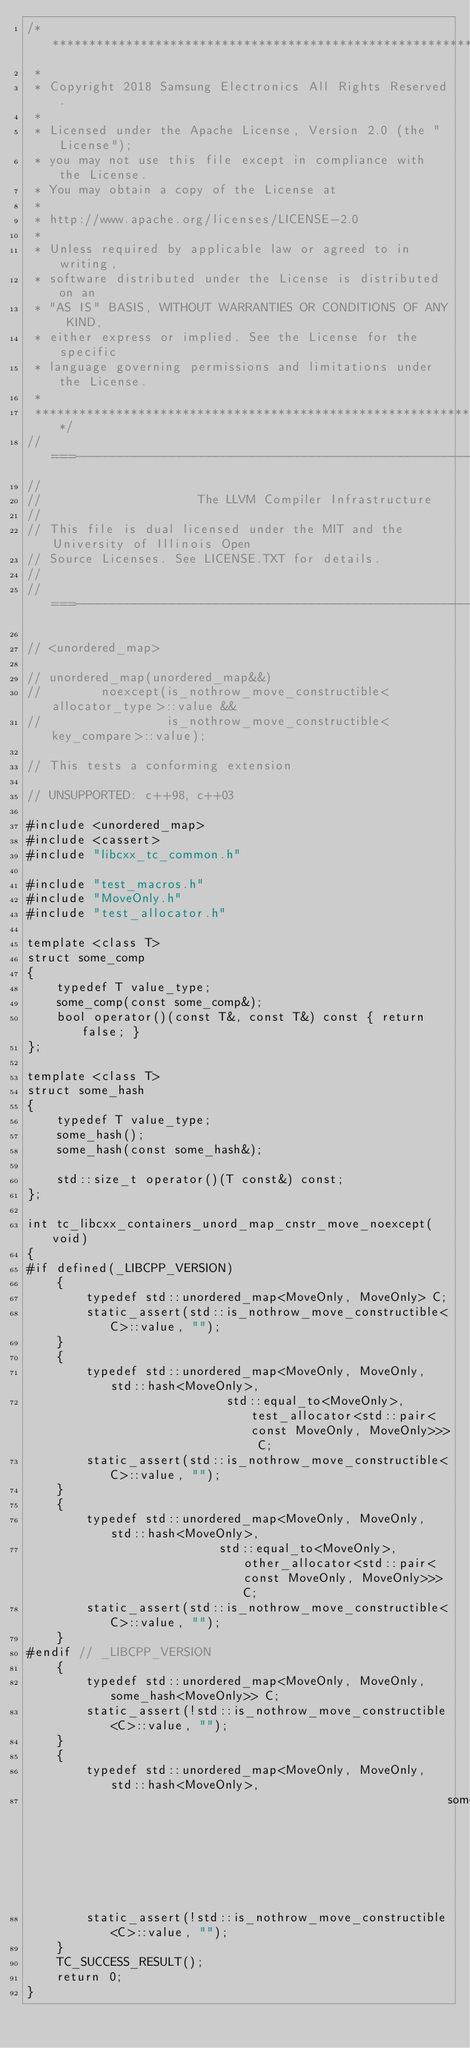<code> <loc_0><loc_0><loc_500><loc_500><_C++_>/****************************************************************************
 *
 * Copyright 2018 Samsung Electronics All Rights Reserved.
 *
 * Licensed under the Apache License, Version 2.0 (the "License");
 * you may not use this file except in compliance with the License.
 * You may obtain a copy of the License at
 *
 * http://www.apache.org/licenses/LICENSE-2.0
 *
 * Unless required by applicable law or agreed to in writing,
 * software distributed under the License is distributed on an
 * "AS IS" BASIS, WITHOUT WARRANTIES OR CONDITIONS OF ANY KIND,
 * either express or implied. See the License for the specific
 * language governing permissions and limitations under the License.
 *
 ****************************************************************************/
//===----------------------------------------------------------------------===//
//
//                     The LLVM Compiler Infrastructure
//
// This file is dual licensed under the MIT and the University of Illinois Open
// Source Licenses. See LICENSE.TXT for details.
//
//===----------------------------------------------------------------------===//

// <unordered_map>

// unordered_map(unordered_map&&)
//        noexcept(is_nothrow_move_constructible<allocator_type>::value &&
//                 is_nothrow_move_constructible<key_compare>::value);

// This tests a conforming extension

// UNSUPPORTED: c++98, c++03

#include <unordered_map>
#include <cassert>
#include "libcxx_tc_common.h"

#include "test_macros.h"
#include "MoveOnly.h"
#include "test_allocator.h"

template <class T>
struct some_comp
{
    typedef T value_type;
    some_comp(const some_comp&);
    bool operator()(const T&, const T&) const { return false; }
};

template <class T>
struct some_hash
{
    typedef T value_type;
    some_hash();
    some_hash(const some_hash&);

    std::size_t operator()(T const&) const;
};

int tc_libcxx_containers_unord_map_cnstr_move_noexcept(void)
{
#if defined(_LIBCPP_VERSION)
    {
        typedef std::unordered_map<MoveOnly, MoveOnly> C;
        static_assert(std::is_nothrow_move_constructible<C>::value, "");
    }
    {
        typedef std::unordered_map<MoveOnly, MoveOnly, std::hash<MoveOnly>,
                           std::equal_to<MoveOnly>, test_allocator<std::pair<const MoveOnly, MoveOnly>>> C;
        static_assert(std::is_nothrow_move_constructible<C>::value, "");
    }
    {
        typedef std::unordered_map<MoveOnly, MoveOnly, std::hash<MoveOnly>,
                          std::equal_to<MoveOnly>, other_allocator<std::pair<const MoveOnly, MoveOnly>>> C;
        static_assert(std::is_nothrow_move_constructible<C>::value, "");
    }
#endif // _LIBCPP_VERSION
    {
        typedef std::unordered_map<MoveOnly, MoveOnly, some_hash<MoveOnly>> C;
        static_assert(!std::is_nothrow_move_constructible<C>::value, "");
    }
    {
        typedef std::unordered_map<MoveOnly, MoveOnly, std::hash<MoveOnly>,
                                                         some_comp<MoveOnly>> C;
        static_assert(!std::is_nothrow_move_constructible<C>::value, "");
    }
    TC_SUCCESS_RESULT();
    return 0;
}
</code> 